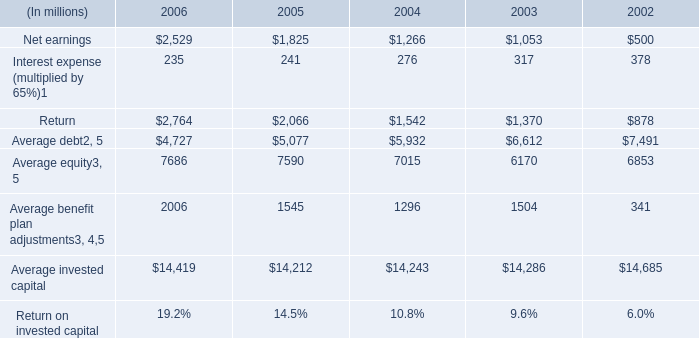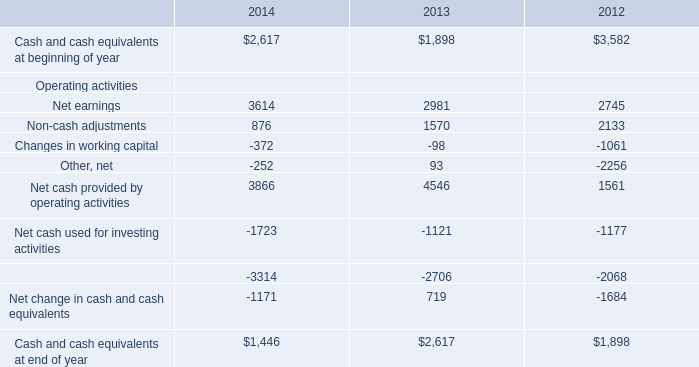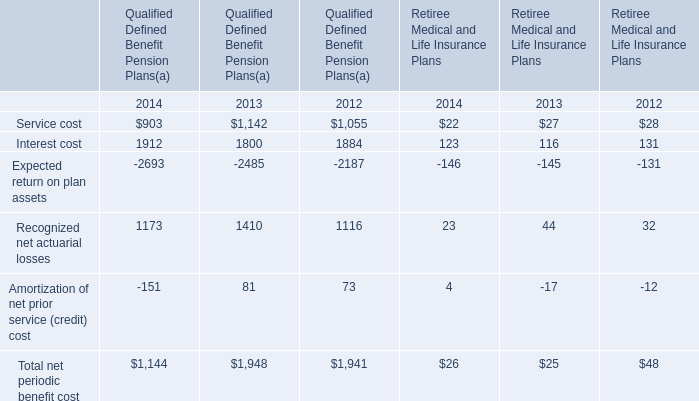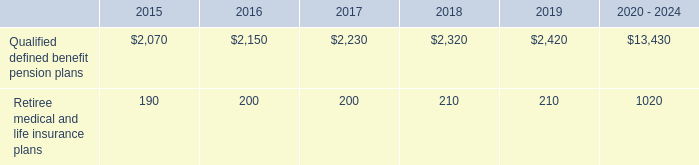what was the average employee contributions from 2012 to 2014 
Computations: (((385 + 383) + 380) / 3)
Answer: 382.66667. 